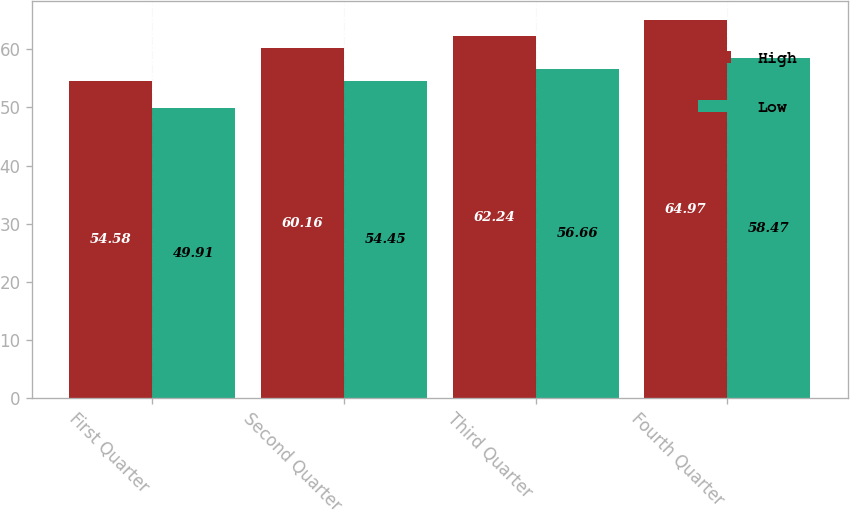Convert chart to OTSL. <chart><loc_0><loc_0><loc_500><loc_500><stacked_bar_chart><ecel><fcel>First Quarter<fcel>Second Quarter<fcel>Third Quarter<fcel>Fourth Quarter<nl><fcel>High<fcel>54.58<fcel>60.16<fcel>62.24<fcel>64.97<nl><fcel>Low<fcel>49.91<fcel>54.45<fcel>56.66<fcel>58.47<nl></chart> 